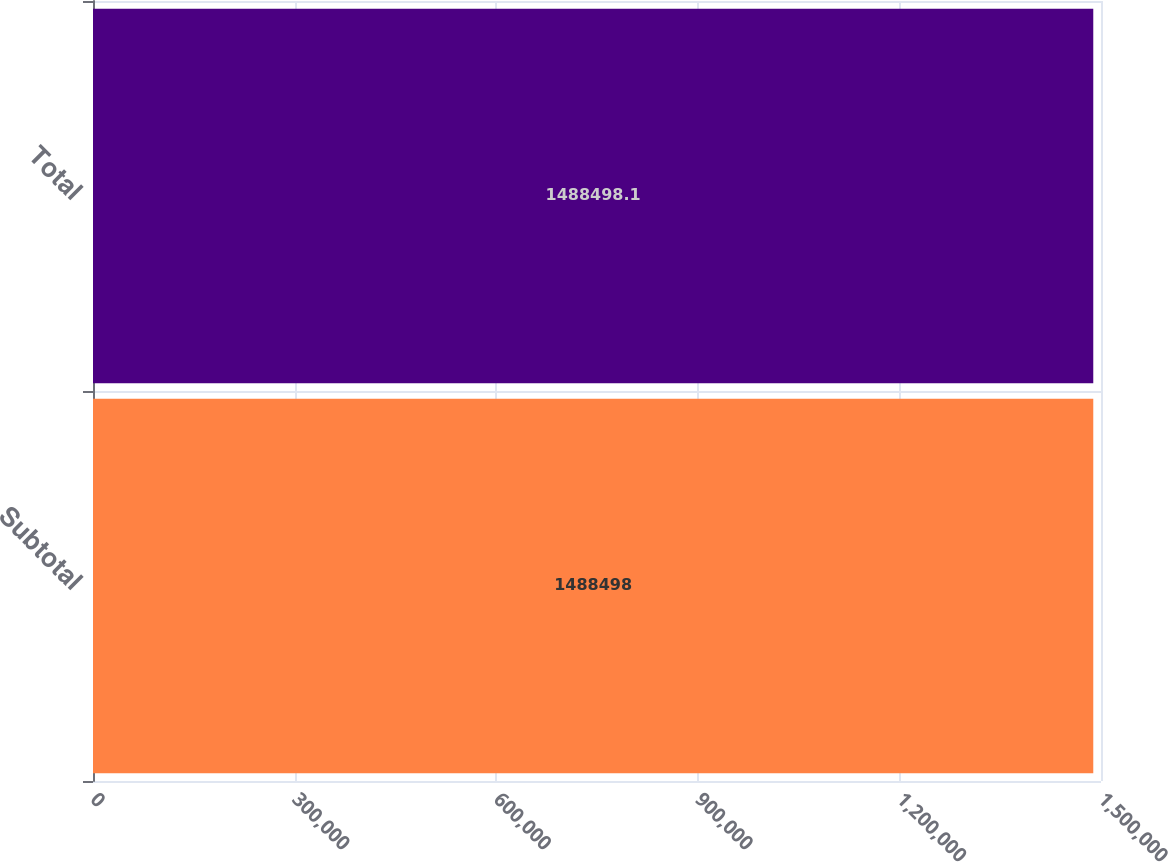<chart> <loc_0><loc_0><loc_500><loc_500><bar_chart><fcel>Subtotal<fcel>Total<nl><fcel>1.4885e+06<fcel>1.4885e+06<nl></chart> 